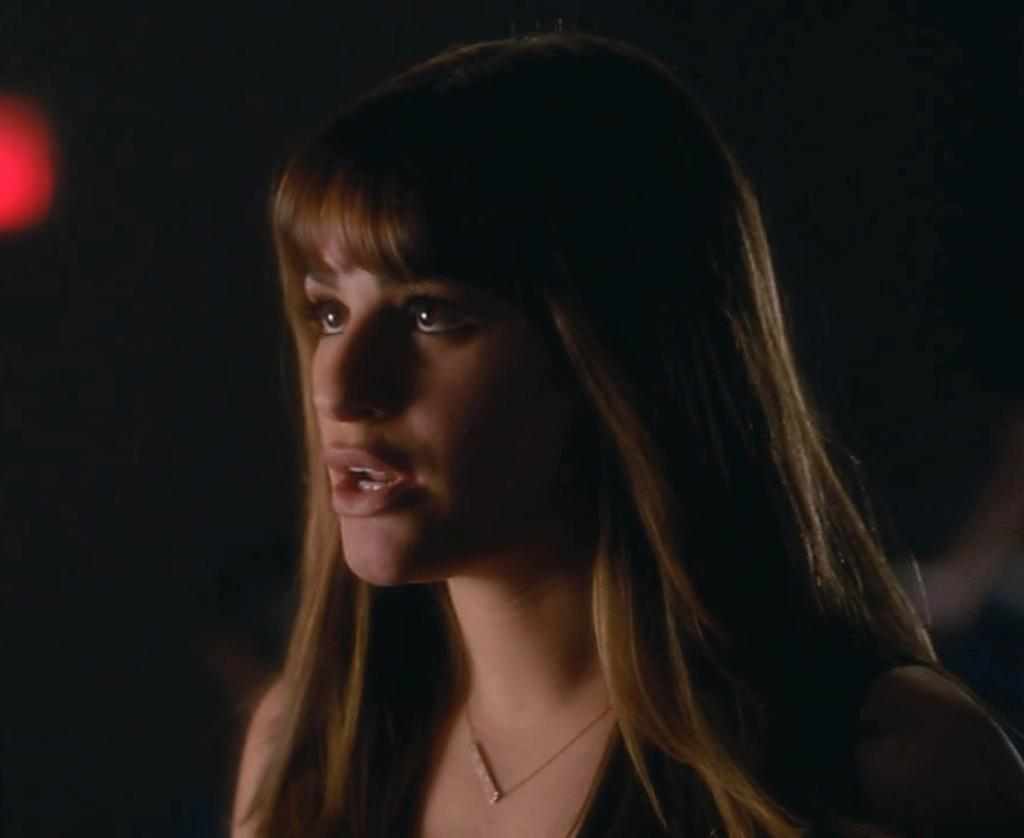Who is present in the image? There is a woman in the image. What is the woman wearing in the image? The woman is wearing a necklace in the image. Where is the necklace located on the woman? The necklace is around her neck. What color is the light in the image? There is a red light in the image. How would you describe the lighting in the background of the image? The background of the image appears dark. Can you see any mountains in the background of the image? There are no mountains visible in the background of the image. What type of beast is interacting with the woman in the image? There is no beast present in the image; it only features a woman wearing a necklace. 